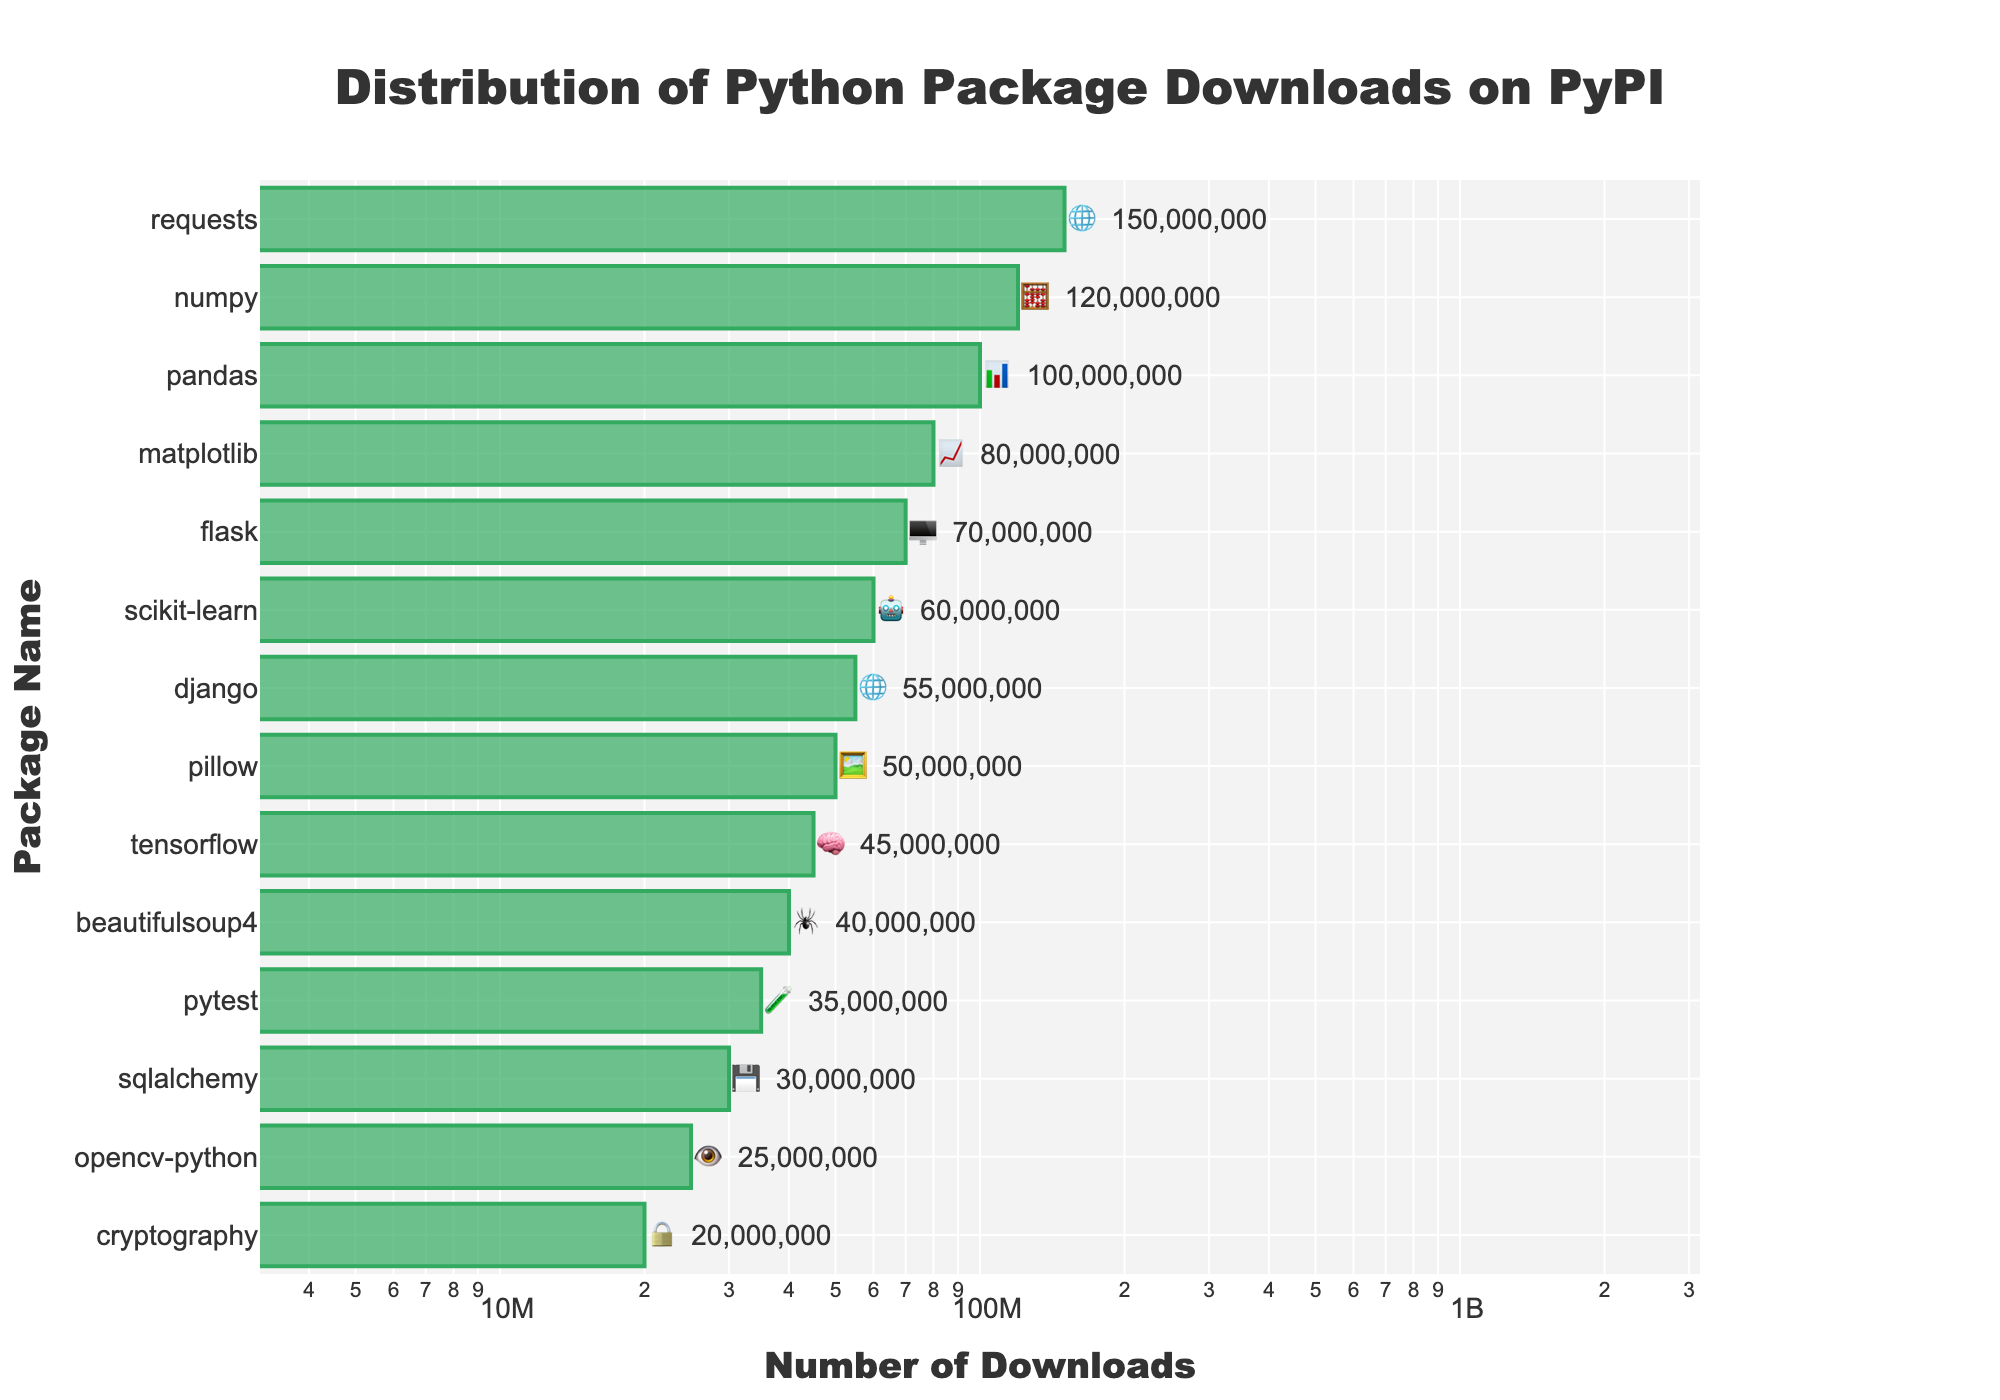What is the package with the highest number of downloads? The package with the highest number of downloads is the one at the top of the bar chart. Here, it is 'requests'.
Answer: requests What is the emoji representation for the 'Data Analysis' category? Find the 'Data Analysis' category in the bar chart, which is represented by 'pandas'. The emoji beside 'pandas' is 📊.
Answer: 📊 Which package in the 'Web Framework' category has fewer downloads: Flask or Django? Compare the download numbers for Flask and Django. Flask has 70,000,000 downloads and Django has 55,000,000 downloads. Django has fewer downloads.
Answer: Django How many packages have over 80,000,000 downloads? Count the packages with download numbers above 80,000,000. The packages are 'requests' and 'numpy'.
Answer: 2 Is the 'Computer Vision' category among the top five most downloaded categories? Check the 'Computer Vision' category represented by 'opencv-python', and see if it is within the top five packages by downloads. It is not, as it ranks 13th.
Answer: No What is the total number of downloads for Machine Learning packages? Sum the downloads for 'scikit-learn' (60,000,000) and 'tensorflow' (45,000,000). The total is 105,000,000 downloads.
Answer: 105,000,000 Which package is the least downloaded one? The least downloaded package is the one at the bottom of the chart: 'cryptography' with 20,000,000 downloads.
Answer: cryptography What is the difference in downloads between 'pandas' and 'matplotlib'? Subtract the downloads of 'matplotlib' (80,000,000) from 'pandas' (100,000,000). The difference is 20,000,000 downloads.
Answer: 20,000,000 What is the category and emoji indicator for the package with the second-highest downloads? The second-highest downloads package is 'numpy' in the 'Scientific' category with the emoji 🧮.
Answer: Scientific 🧮 